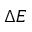<formula> <loc_0><loc_0><loc_500><loc_500>\Delta E</formula> 